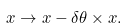Convert formula to latex. <formula><loc_0><loc_0><loc_500><loc_500>x \rightarrow x - \delta \theta \times x .</formula> 